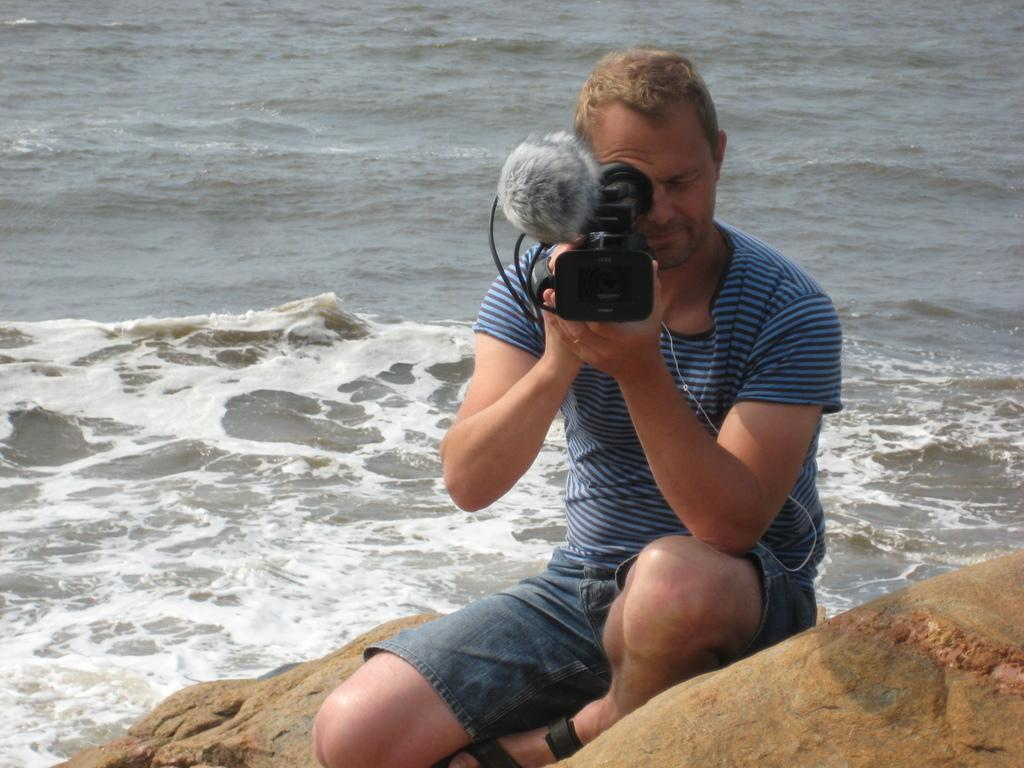Who is the main subject in the image? There is a man in the image. What is the man doing in the image? The man is sitting on a rock. What is the man holding in the image? The man is holding a camera. What can be seen in the background of the image? There is an ocean in the background of the image. What color is the man's T-shirt in the image? The man is wearing a blue T-colored T-shirt. Where is the map located in the image? There is no map present in the image. Can you describe the apple that the girl is holding in the image? There is no girl or apple present in the image. 